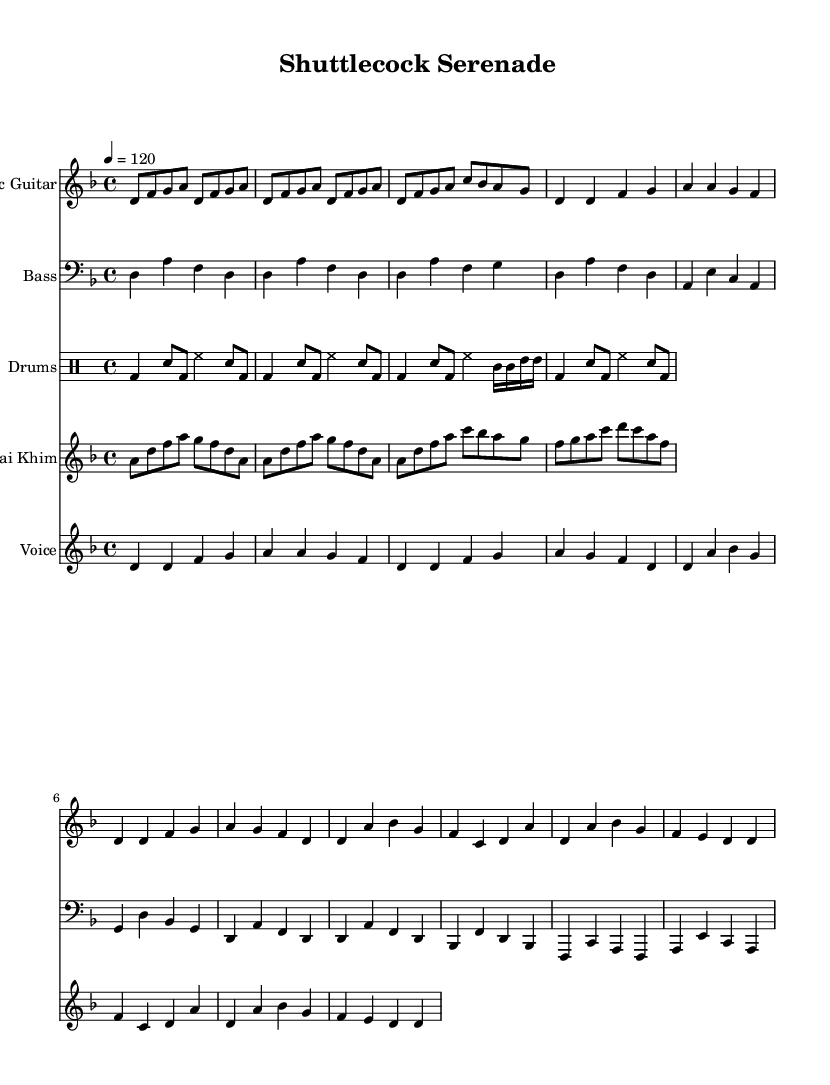What is the key signature of this music? The key signature is D minor, which has one flat (B flat). This is evident from the global settings at the beginning of the code indicating the key.
Answer: D minor What is the time signature of this music? The time signature is 4/4, which can be found in the global settings of the provided music code. This indicates that there are four beats in each measure.
Answer: 4/4 What is the tempo marking of this music? The tempo marking is 120 BPM, as stated in the global settings. This indicates how fast the music should be played, with a quarter note equaling 120 beats per minute.
Answer: 120 How many measures are in the intro section? The intro section consists of 3 measures, as indicated by the grouping of notes in the electric guitar part. The notation visually shows 3 complete segments before moving to the verse.
Answer: 3 What type of percussion is primarily used in this composition? The primary percussion used in this composition is the drum set, specifically indicated by the "drumsPart" section. This includes various elements like bass drum, snare, and toms.
Answer: Drum set What scale influence is emphasized in the Khim part? The Khim part emphasizes a pentatonic scale, shown by the series of notes that align well with the common five-note scale structure typical in Southeast Asian music.
Answer: Pentatonic What is the relationship between the verse and chorus sections? The verse and chorus sections follow a contrasting pattern, where the verse is more melodic and repetitive, while the chorus introduces different harmonies and a higher range, illustrating a typical structure of Rock music.
Answer: Contrast 